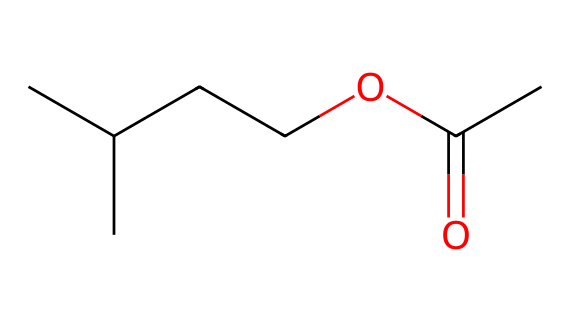How many carbon atoms are in isoamyl acetate? The SMILES representation indicates the presence of carbon atoms. Counting the 'C's in the structure, we find 7 carbon atoms (5 from the branching and 2 from the ester part).
Answer: 7 What functional group is present in isoamyl acetate? The ester functional group is characterized by the presence of a carbonyl (C=O) and an alkoxy group (O-R). In the given structure, the -C(O)OC- indicates the ester group.
Answer: ester How many oxygen atoms are in isoamyl acetate? In the SMILES representation, there are 2 instances of 'O', signifying that there are 2 oxygen atoms present in the structure of isoamyl acetate.
Answer: 2 What type of bonding primarily exists between the carbon and oxygen in the ester functional group? The carbon-oxygen bonds in the ester functional group include one double bond (C=O) and one single bond (C-O). This indicates both kinds of bonding are present.
Answer: double and single What does the presence of branched carbon chains in isoamyl acetate indicate about its molecular structure? Branched carbon chains in a molecule typically suggest a certain degree of steric hindrance and can influence the volatility and solubility of the compound. In this case, it gives the molecule its characteristic banana-like scent.
Answer: steric hindrance Which aspect of isoamyl acetate contributes to its banana-like scent? The specific arrangement of the carbon chains, particularly the isoamyl group, combined with the ester functional group, is key to the fruity aroma associated with isoamyl acetate.
Answer: isoamyl group What would happen to the solubility of isoamyl acetate if one of its carbon chains were to be straightened? If one of the carbon chains were straightened, the molecule could become less soluble in water due to reduced steric interactions and an increase in hydrophobicity. This would impact its use as a fragrance.
Answer: less soluble 